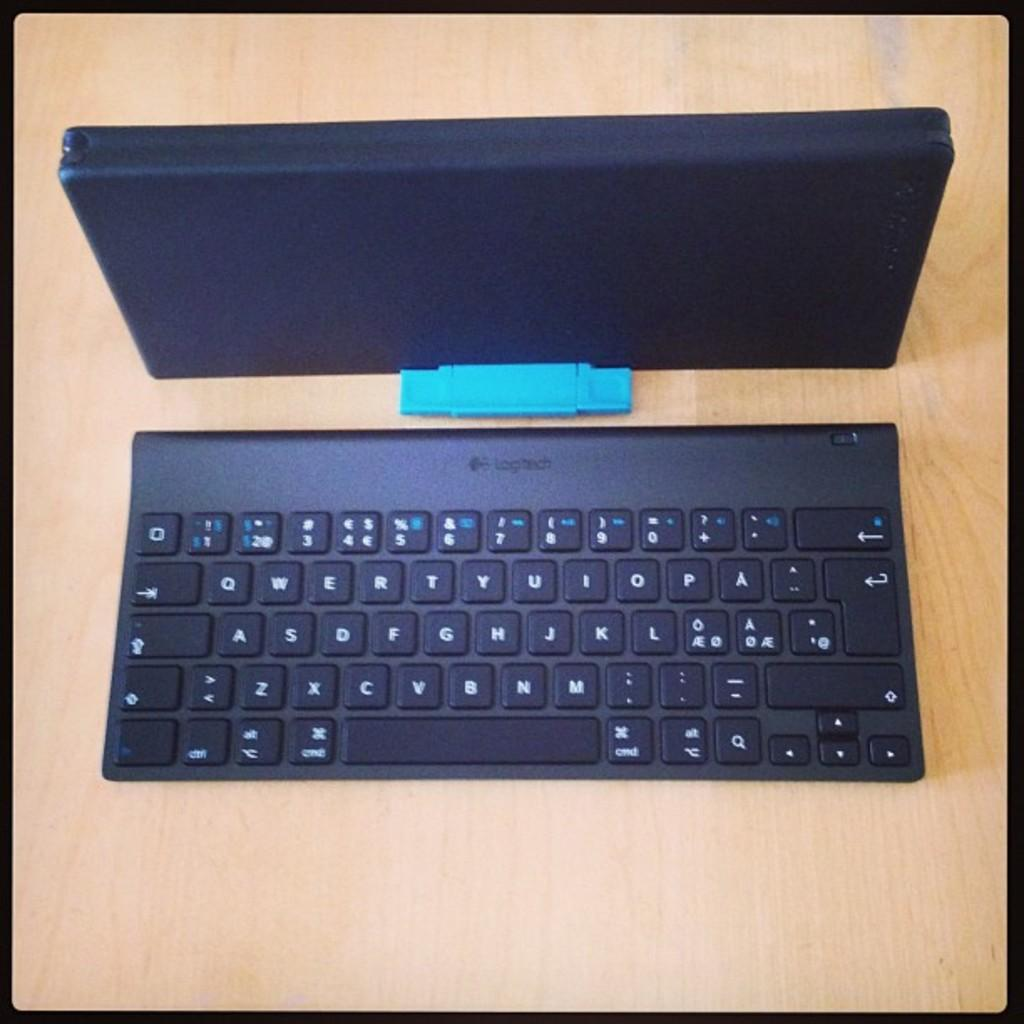<image>
Present a compact description of the photo's key features. A Logitech keyboard is next to its box on a wooden table. 